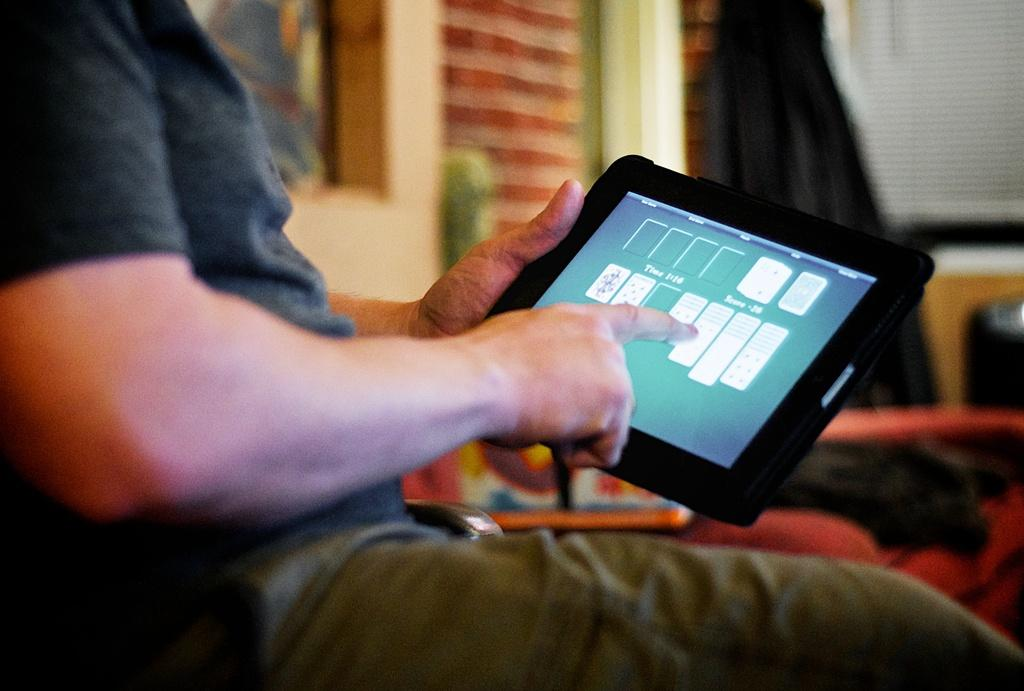Who is present in the image? There is a man in the image. What is the man doing in the image? The man is sitting on a chair and using an iPad. What type of stove is visible in the image? There is no stove present in the image. What kind of party is the man attending in the image? There is no party depicted in the image; the man is simply sitting on a chair and using an iPad. 